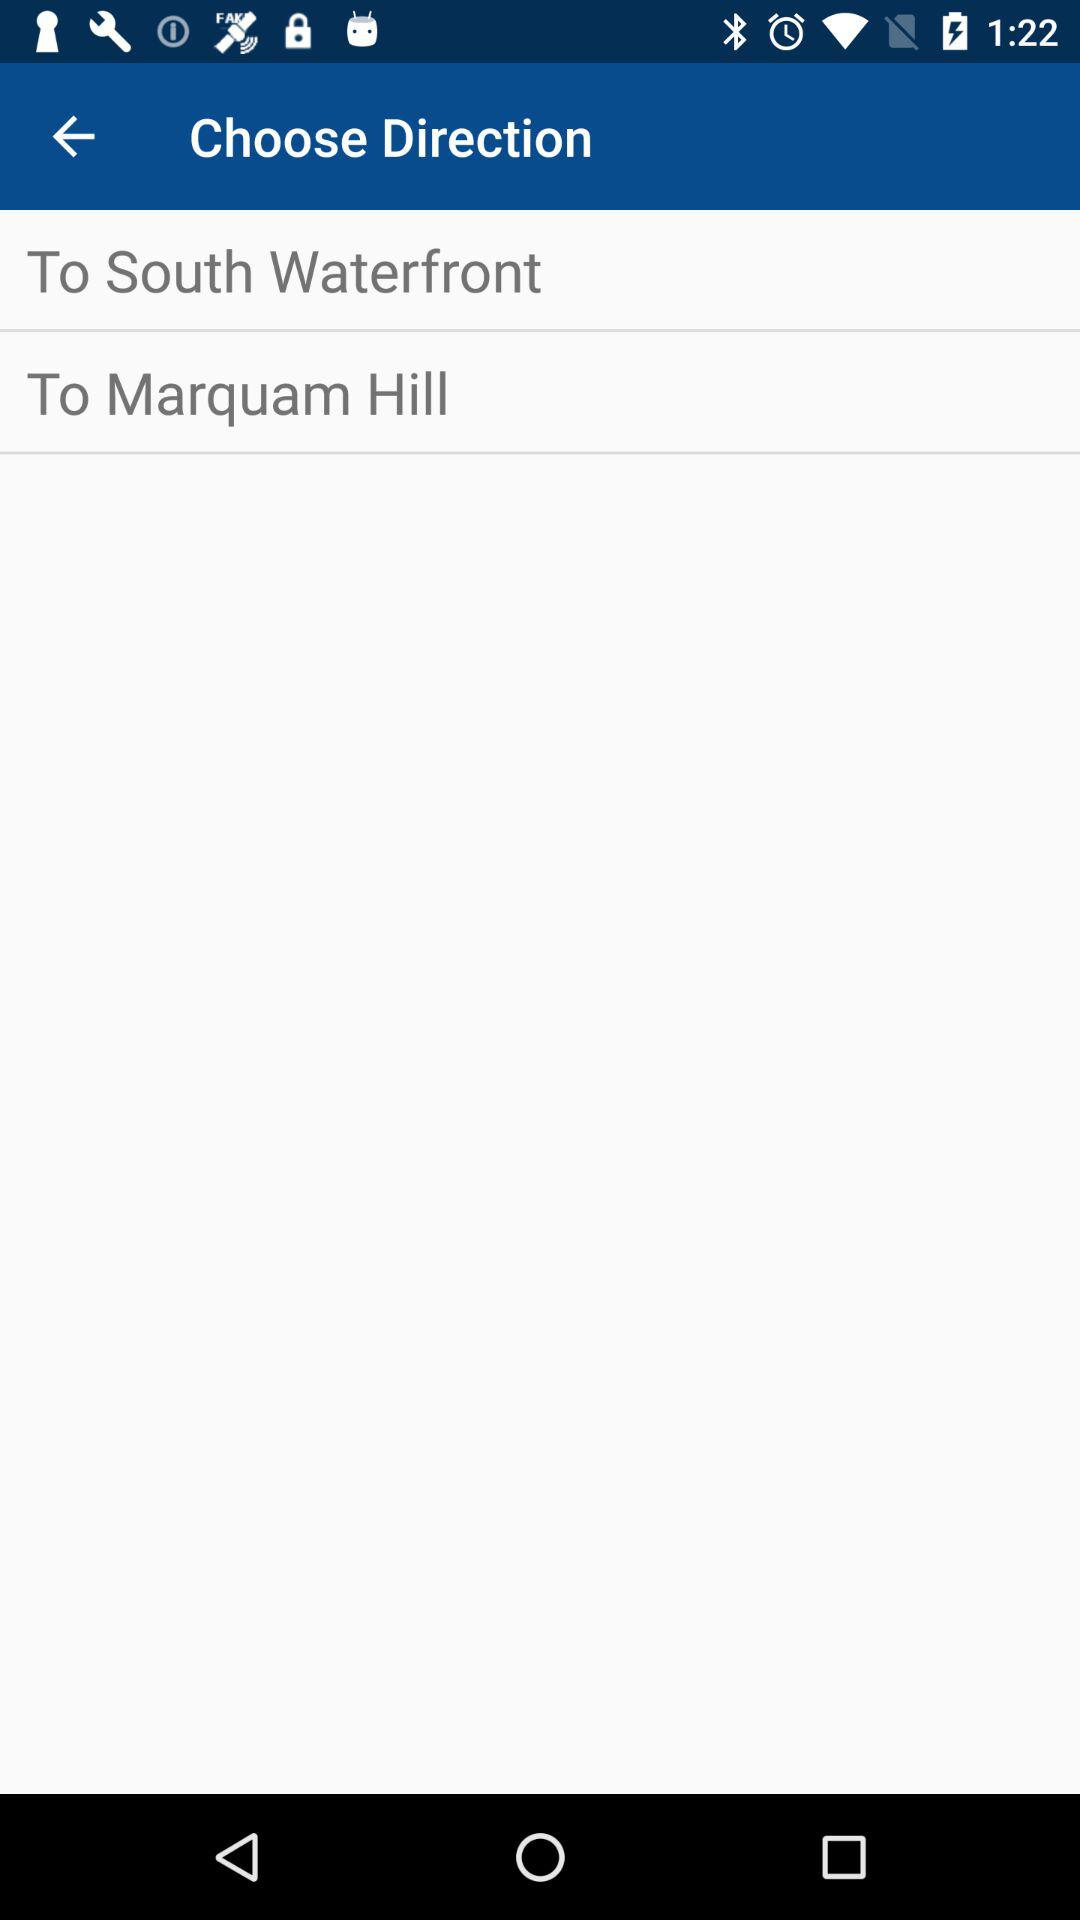How many directions are available to choose from?
Answer the question using a single word or phrase. 2 